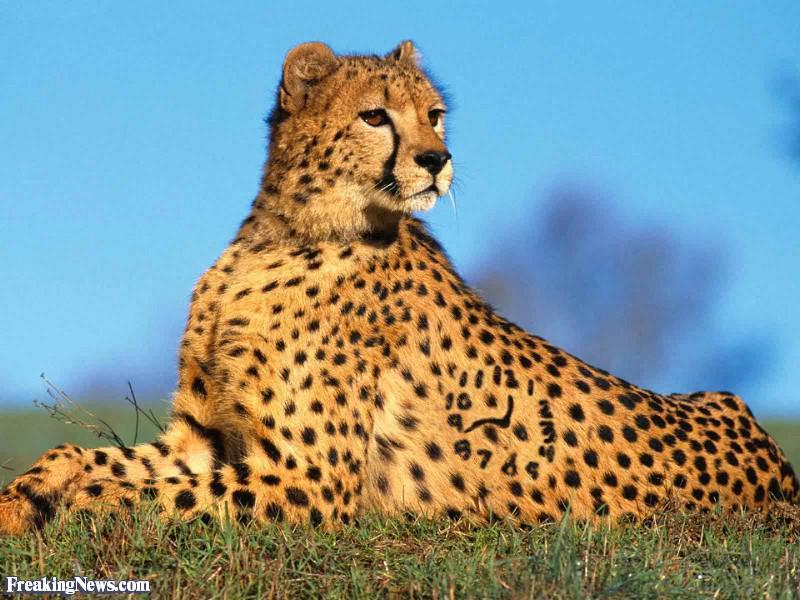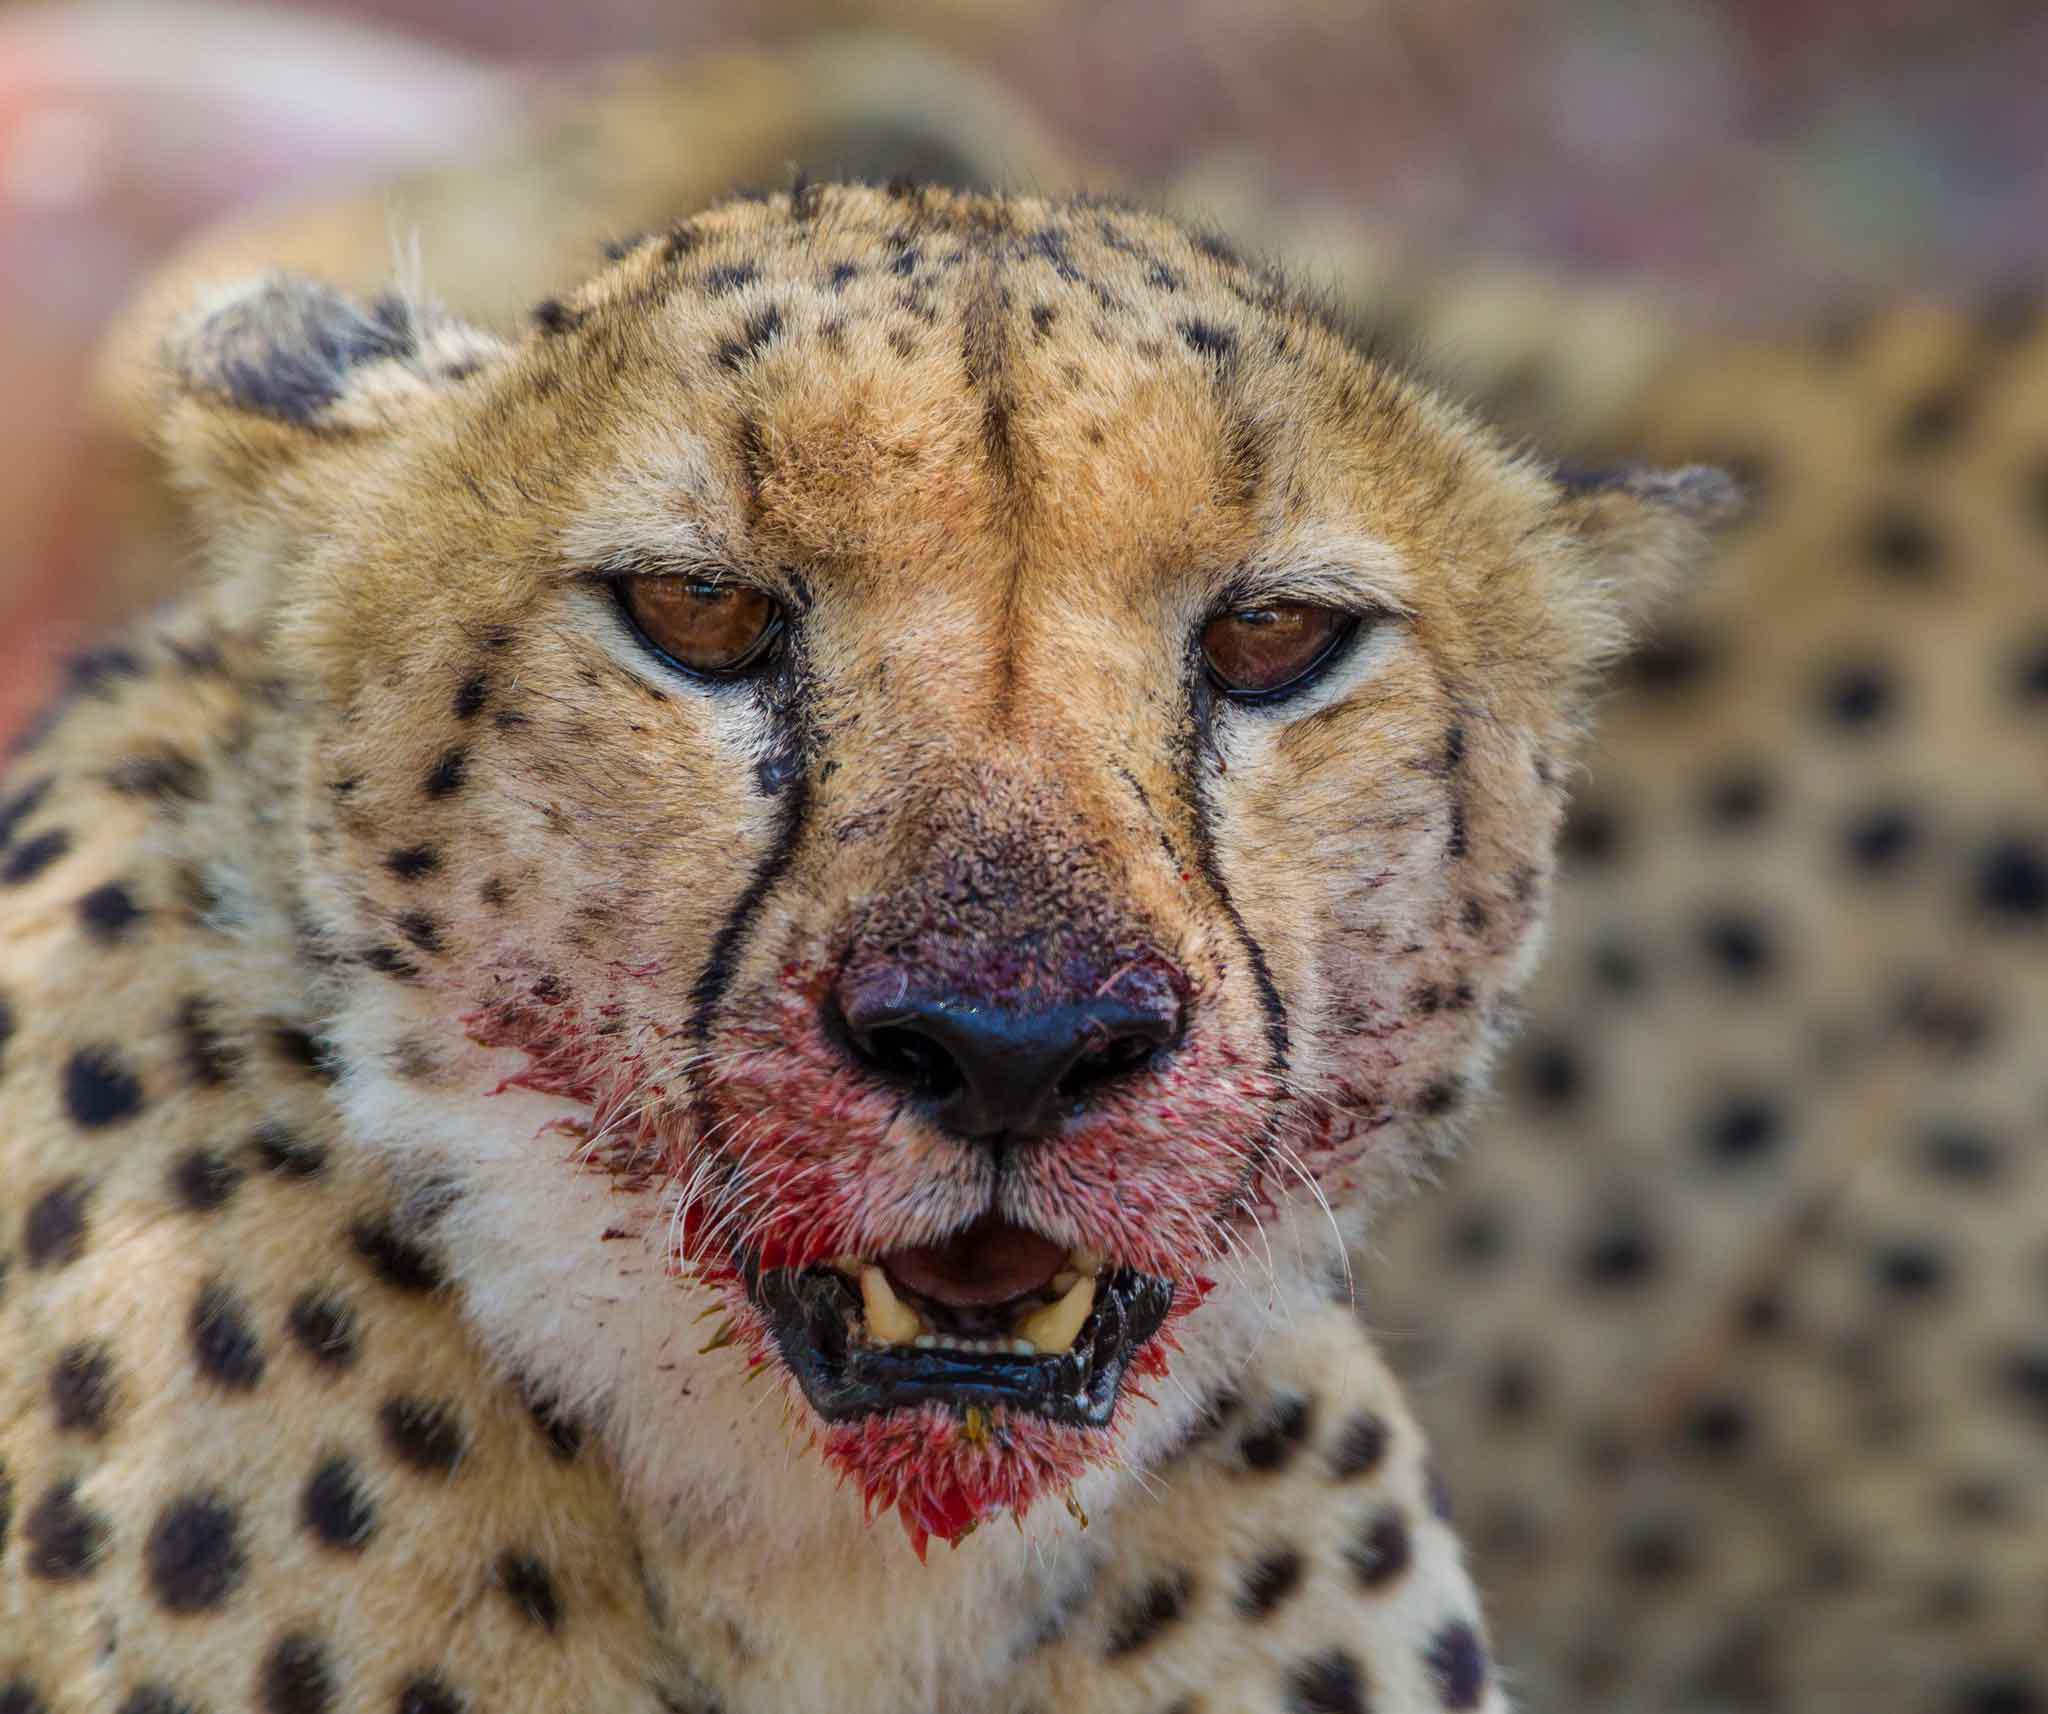The first image is the image on the left, the second image is the image on the right. For the images shown, is this caption "At least one cheetah has blood around its mouth." true? Answer yes or no. Yes. The first image is the image on the left, the second image is the image on the right. Given the left and right images, does the statement "The left image includes at least one cheetah in a reclining pose with both its front paws forward, and the right image includes a cheetah with a blood-drenched muzzle." hold true? Answer yes or no. Yes. 